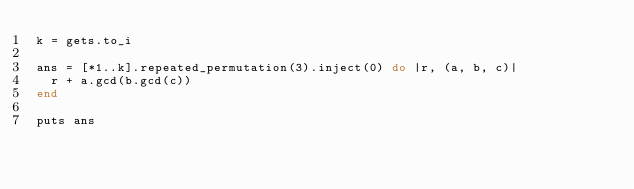Convert code to text. <code><loc_0><loc_0><loc_500><loc_500><_Ruby_>k = gets.to_i

ans = [*1..k].repeated_permutation(3).inject(0) do |r, (a, b, c)|
  r + a.gcd(b.gcd(c))
end

puts ans
</code> 